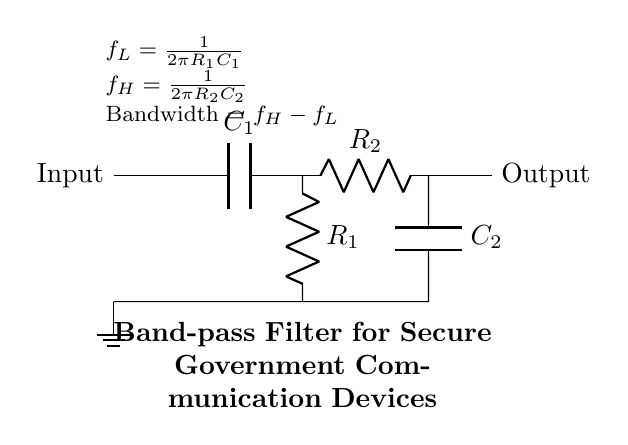What components are used in this circuit? The circuit diagram includes two capacitors (C1 and C2) and two resistors (R1 and R2). Each component plays a role in determining the filter characteristics.
Answer: Capacitors and resistors What is the purpose of this circuit? This circuit acts as a band-pass filter, which allows signals between two specific frequencies to pass while attenuating signals outside that range. It is used for secure government communications, allowing only necessary frequencies.
Answer: Band-pass filter What is the formula for the lower cutoff frequency? The formula for the lower cutoff frequency fL is given as fL = 1/(2πR1C1). This formula indicates how the values of R1 and C1 affect the frequency at which the signal starts to pass through the filter.
Answer: fL = 1/(2πR1C1) What are the two cutoff frequencies of the band-pass filter? The low cutoff frequency (fL) and high cutoff frequency (fH) are calculated using the provided formulas. fH is determined by the values of resistor R2 and capacitor C2.
Answer: fL and fH How is the bandwidth of the filter calculated? The bandwidth is calculated as the difference between the high and low cutoff frequencies, expressed mathematically as Bandwidth = fH - fL. This shows the range of frequencies that the filter allows to pass through.
Answer: Bandwidth = fH - fL What are the values that define the volume of the bandwidth? The bandwidth is defined by the resistors and capacitors, specifically through the equations that govern the cutoff frequencies fL and fH. The specific values of R1, R2, C1, and C2 will result in different bandwidths based on these calculations.
Answer: R1, R2, C1, C2 values 